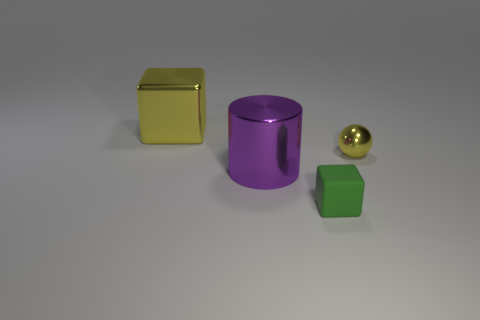Is there any other thing that has the same shape as the big purple shiny object?
Provide a succinct answer. No. Does the cylinder in front of the yellow metal sphere have the same size as the yellow shiny object behind the small shiny object?
Provide a short and direct response. Yes. Do the large yellow block and the tiny thing that is on the left side of the sphere have the same material?
Offer a terse response. No. Is the number of small balls that are left of the green rubber object greater than the number of big yellow blocks that are right of the large purple cylinder?
Offer a very short reply. No. There is a large object right of the shiny thing that is behind the metallic ball; what color is it?
Provide a succinct answer. Purple. How many cylinders are either purple objects or matte objects?
Keep it short and to the point. 1. How many yellow things are both on the left side of the yellow shiny ball and right of the yellow shiny block?
Provide a short and direct response. 0. What is the color of the block that is behind the tiny metal thing?
Offer a terse response. Yellow. The other yellow thing that is the same material as the big yellow object is what size?
Give a very brief answer. Small. There is a cube that is behind the small green cube; what number of purple shiny things are left of it?
Offer a terse response. 0. 